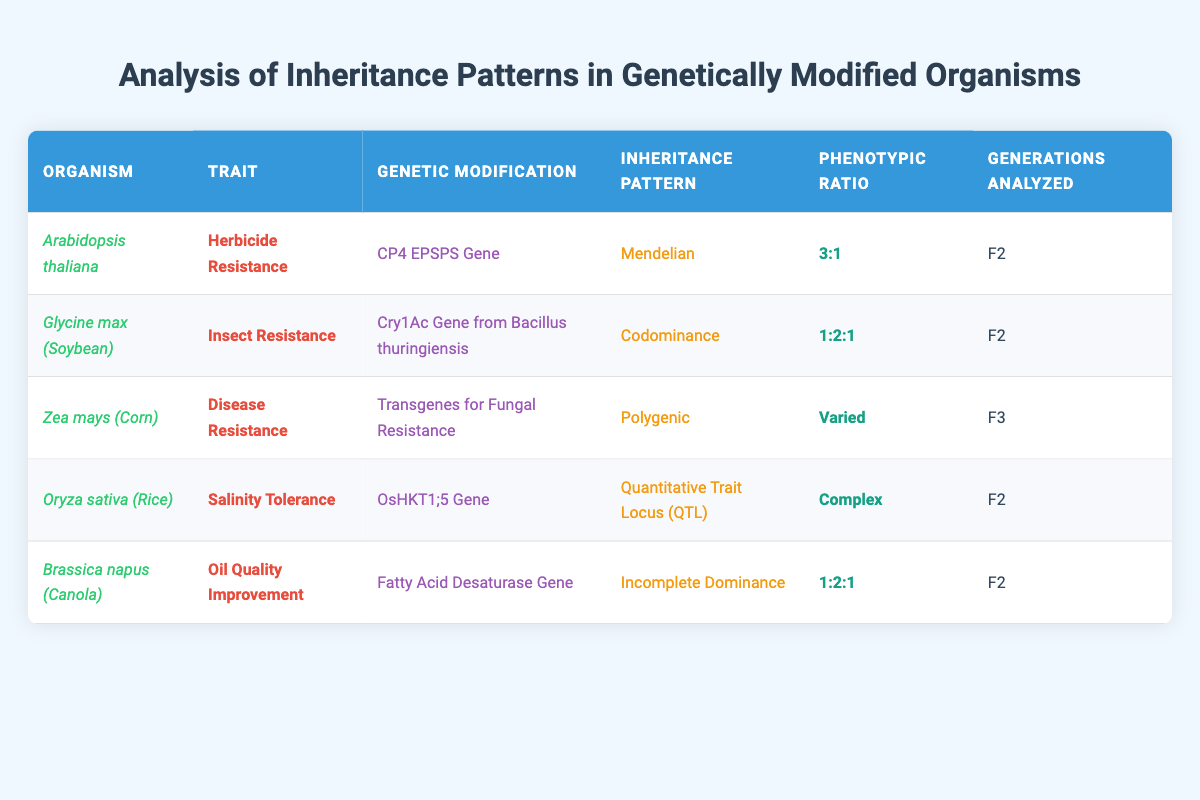What genetic modification is used for herbicide resistance in Arabidopsis thaliana? The table indicates that the genetic modification for herbicide resistance in Arabidopsis thaliana is the CP4 EPSPS Gene. This specific gene is mentioned in the row corresponding to Arabidopsis thaliana under the 'Genetic Modification' column.
Answer: CP4 EPSPS Gene Which organism exhibits codominance in inheritance patterns? Upon reviewing the table, Glycine max (Soybean) is the organism that displays codominance as indicated in the 'Inheritance Pattern' column. Therefore, the answer is Glycine max.
Answer: Glycine max (Soybean) How many organisms analyzed have a phenotypic ratio of 1:2:1? By inspecting the table, we observe that two entries, Glycine max (Soybean) and Brassica napus (Canola), have a phenotypic ratio of 1:2:1. Thus, we count them to find the answer.
Answer: 2 Is Zea mays characterized by a Mendelian inheritance pattern? The table shows that Zea mays (Corn) has a polygenic inheritance pattern, not Mendelian. Therefore, the answer is false.
Answer: False What is the inheritance pattern of Oryza sativa and how does its trait differ from that of Brassica napus? Oryza sativa (Rice) has a Quantitative Trait Locus (QTL) inheritance pattern. In contrast, Brassica napus (Canola) exhibits Incomplete Dominance. Thus, Oryza sativa's trait (salinity tolerance) involves quantitative traits, while Brassica napus focuses on quality improvement (oil quality).
Answer: QTL; different traits How many total different inheritance patterns are represented in the table? The inheritance patterns present in the table are: Mendelian, Codominance, Polygenic, Quantitative Trait Locus (QTL), and Incomplete Dominance. Counting these, we find that there are five distinct inheritance patterns indicated.
Answer: 5 What is the phenotypic ratio for disease resistance in Zea mays? The phenotypic ratio for Zea mays (Corn) as per the table is marked as varied. This indicates that the ratio does not fit a standard or fixed format.
Answer: Varied Which organism analyzed has salinity tolerance and how many generations were studied? The organism featuring salinity tolerance is Oryza sativa (Rice), and the table shows that it was analyzed in the F2 generation. This information can be found in the respective columns for each of these data points.
Answer: Oryza sativa; F2 